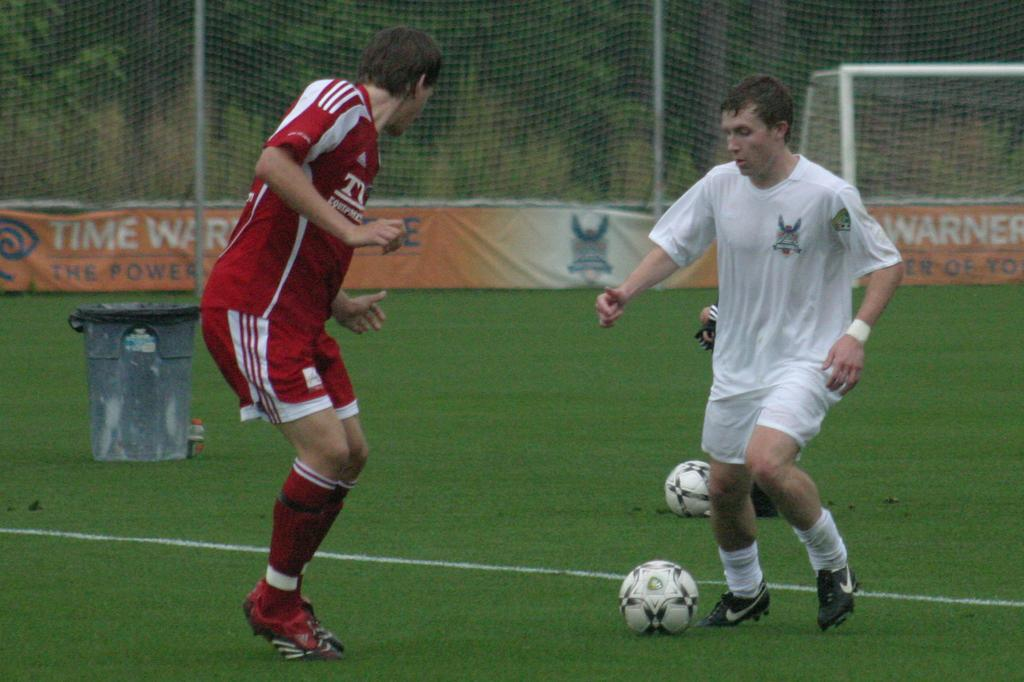<image>
Give a short and clear explanation of the subsequent image. Men play soccer in front of orange signs for Time Warner. 